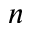Convert formula to latex. <formula><loc_0><loc_0><loc_500><loc_500>n</formula> 